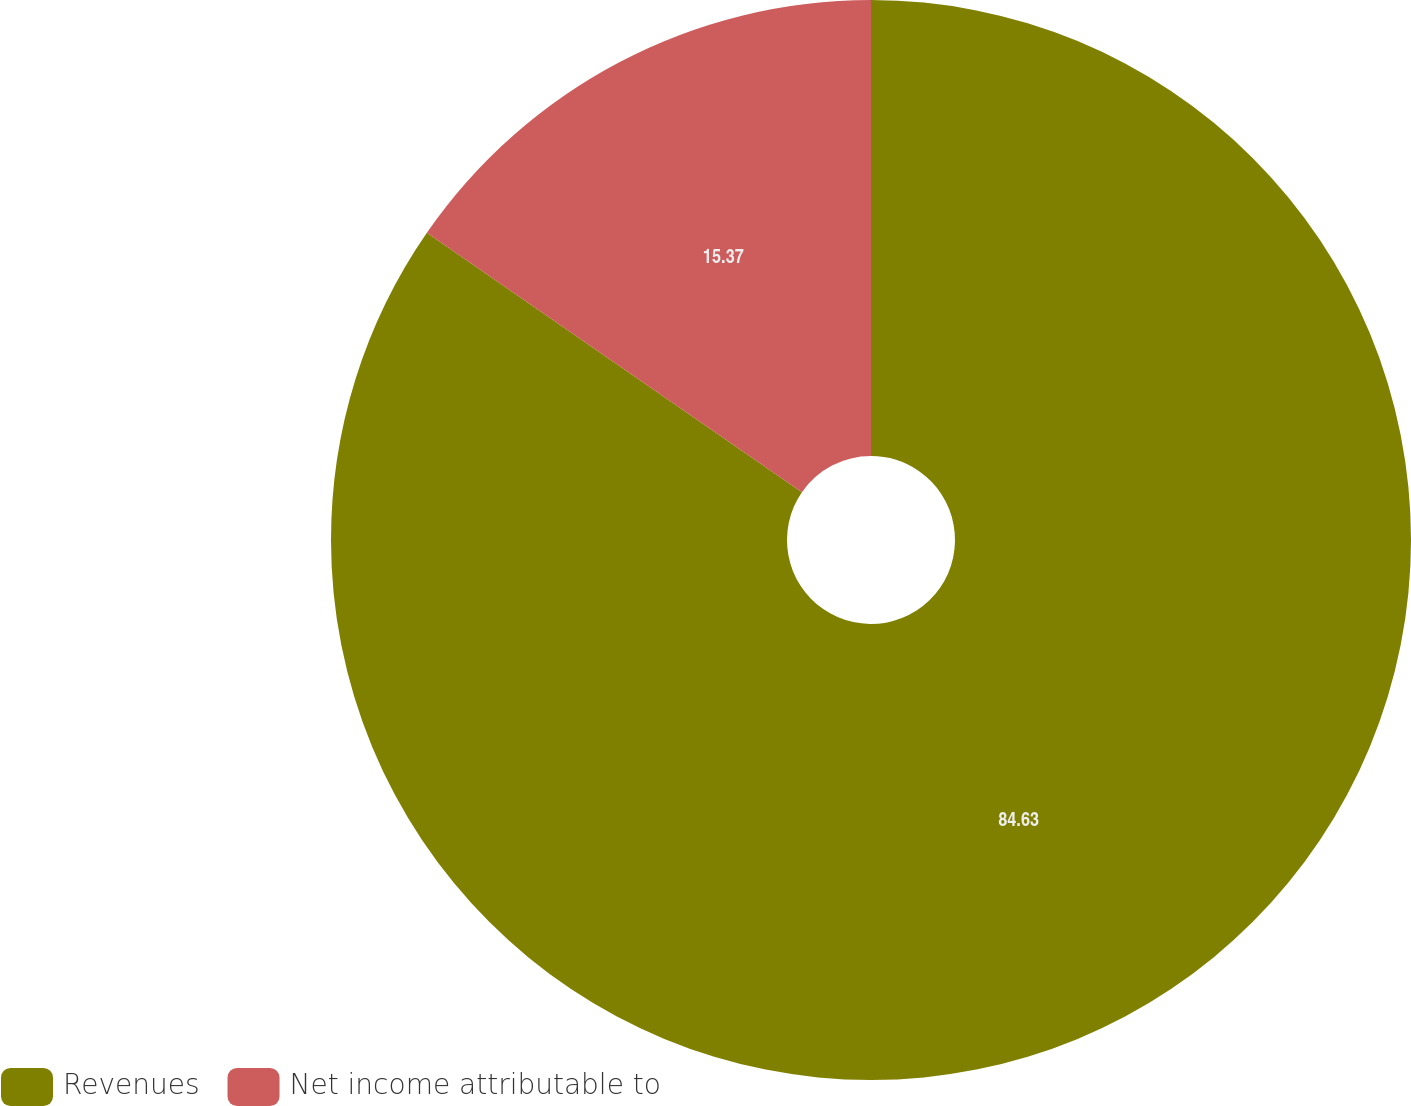Convert chart. <chart><loc_0><loc_0><loc_500><loc_500><pie_chart><fcel>Revenues<fcel>Net income attributable to<nl><fcel>84.63%<fcel>15.37%<nl></chart> 